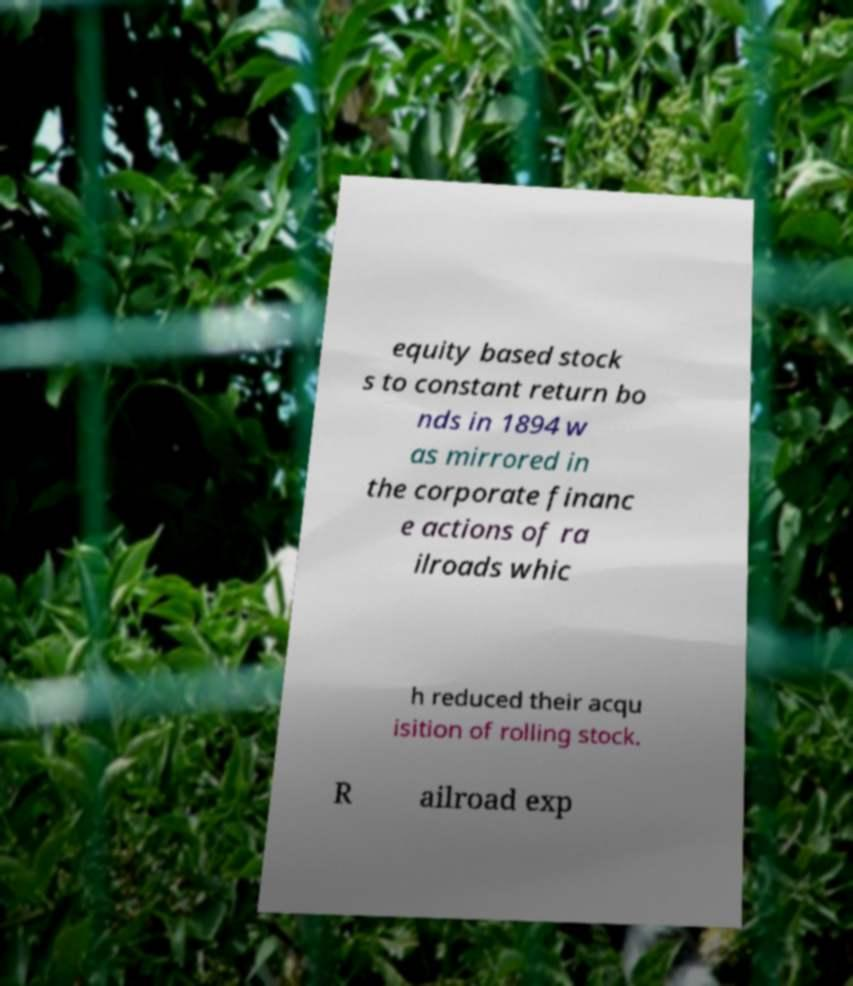Can you read and provide the text displayed in the image?This photo seems to have some interesting text. Can you extract and type it out for me? equity based stock s to constant return bo nds in 1894 w as mirrored in the corporate financ e actions of ra ilroads whic h reduced their acqu isition of rolling stock. R ailroad exp 